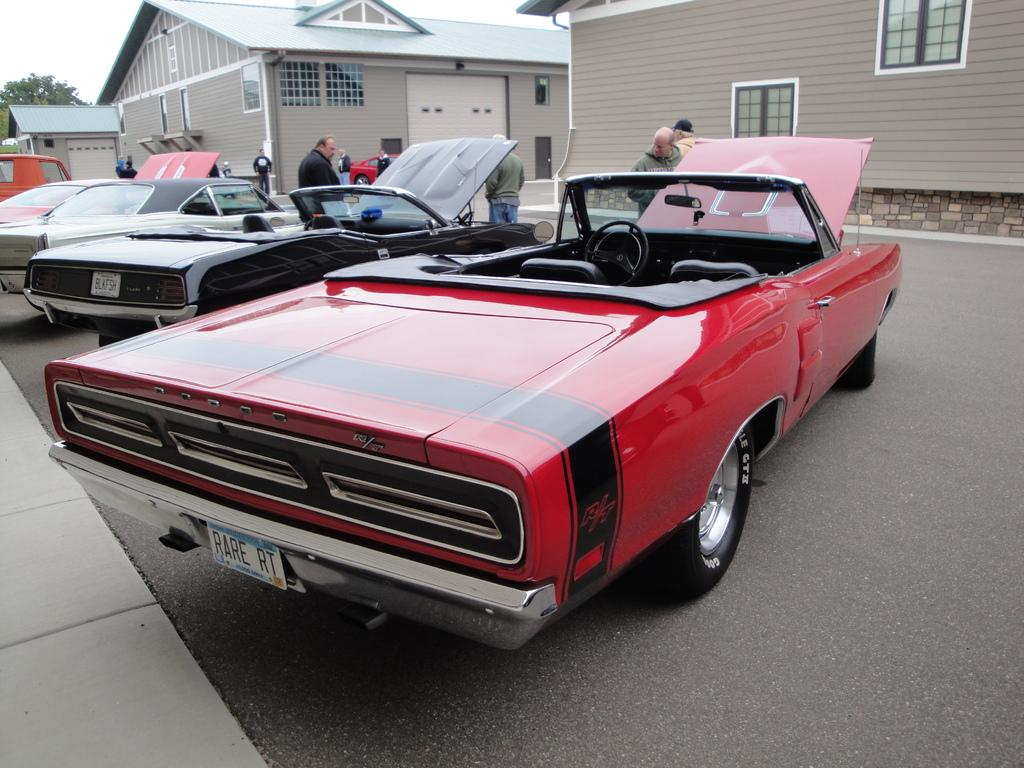What type of structures can be seen in the image? There are houses in the image. What else is visible near the houses? Vehicles are parked beside the houses. What activity is taking place on the road in the image? There are people walking on the road in the image. What type of arithmetic problem is being solved by the donkey in the image? There is no donkey present in the image, and therefore no arithmetic problem is being solved. 